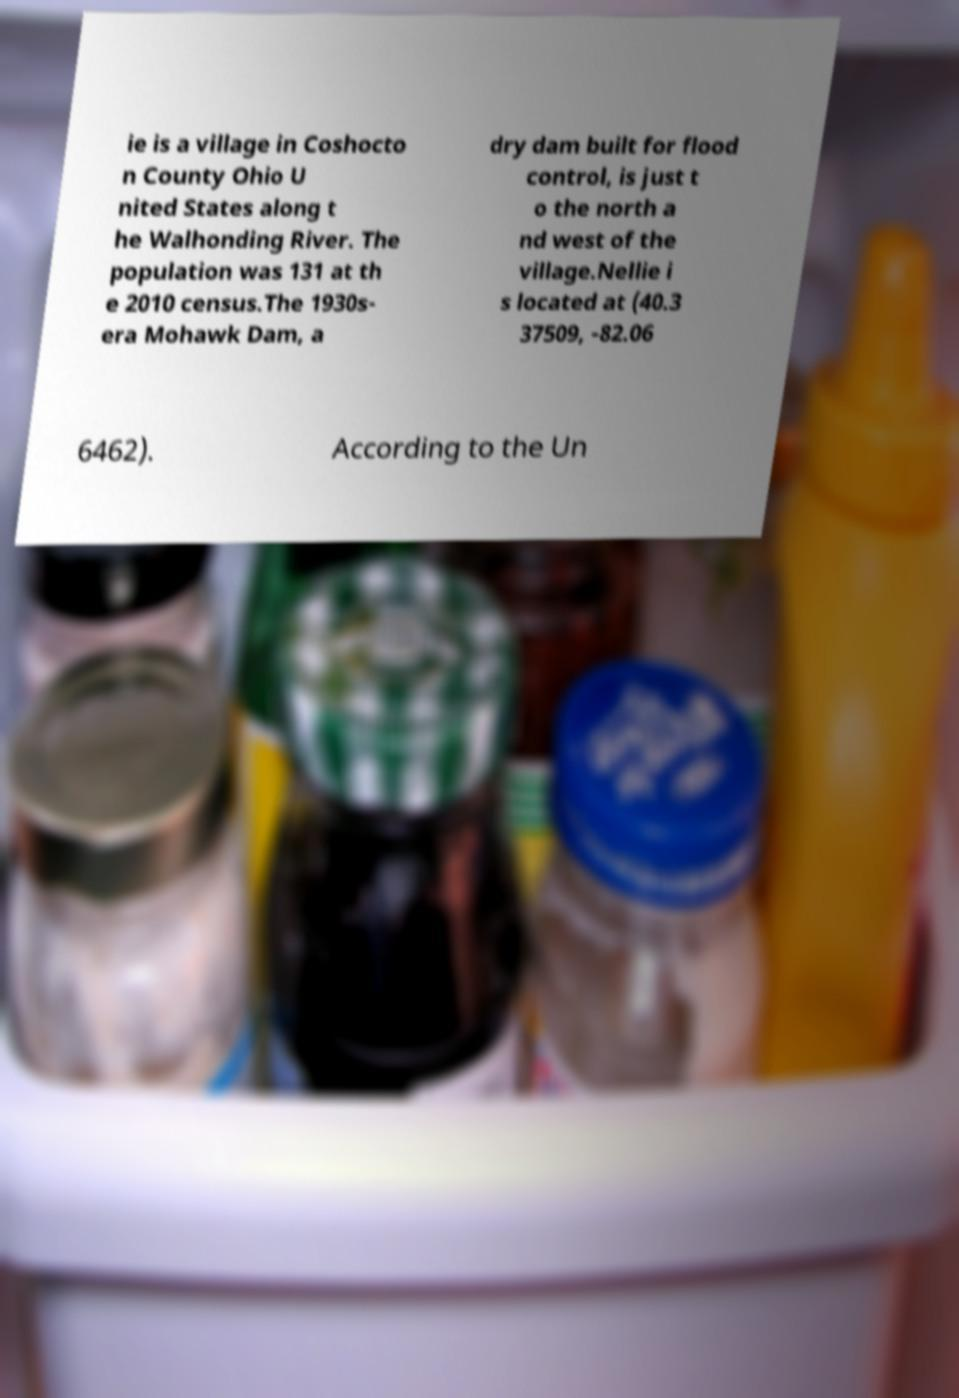Please read and relay the text visible in this image. What does it say? ie is a village in Coshocto n County Ohio U nited States along t he Walhonding River. The population was 131 at th e 2010 census.The 1930s- era Mohawk Dam, a dry dam built for flood control, is just t o the north a nd west of the village.Nellie i s located at (40.3 37509, -82.06 6462). According to the Un 